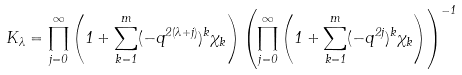<formula> <loc_0><loc_0><loc_500><loc_500>K _ { \lambda } = \prod _ { j = 0 } ^ { \infty } \left ( 1 + \sum _ { k = 1 } ^ { m } ( - q ^ { 2 ( \lambda + j ) } ) ^ { k } \chi _ { k } \right ) \left ( \prod _ { j = 0 } ^ { \infty } \left ( 1 + \sum _ { k = 1 } ^ { m } ( - q ^ { 2 j } ) ^ { k } \chi _ { k } \right ) \right ) ^ { - 1 }</formula> 